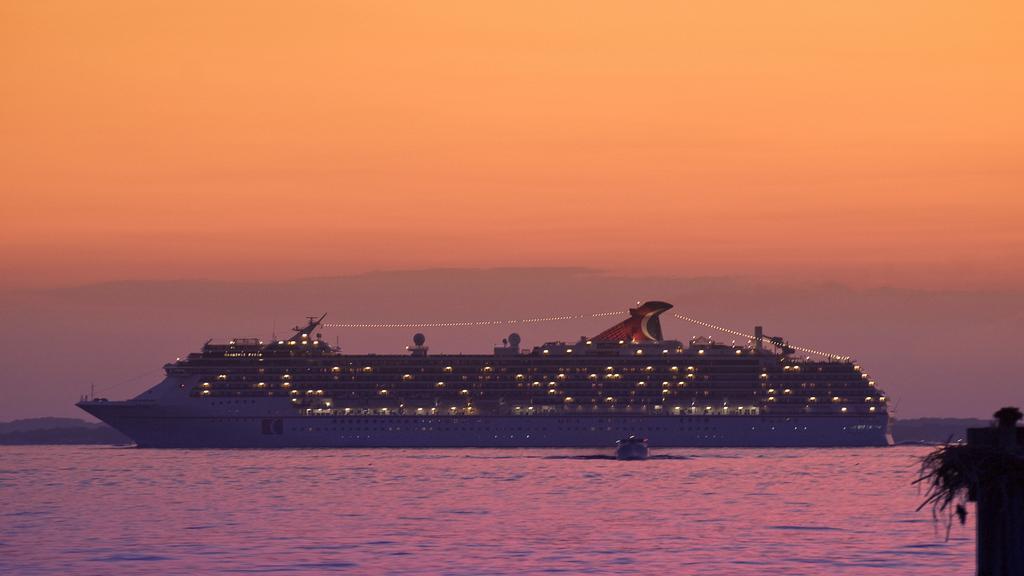Describe this image in one or two sentences. In this image there is a ship and a boat on the water , and in the background there are hills, sky. 